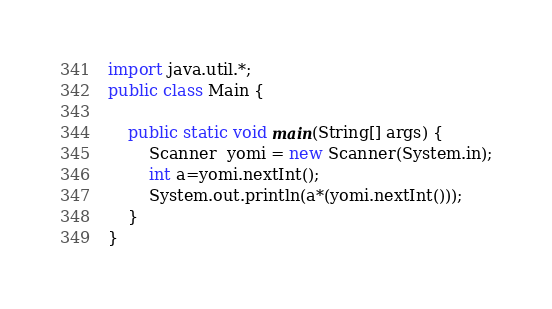Convert code to text. <code><loc_0><loc_0><loc_500><loc_500><_Java_>import java.util.*;
public class Main {

    public static void main(String[] args) {
        Scanner  yomi = new Scanner(System.in);
        int a=yomi.nextInt();
        System.out.println(a*(yomi.nextInt()));
    }
}</code> 